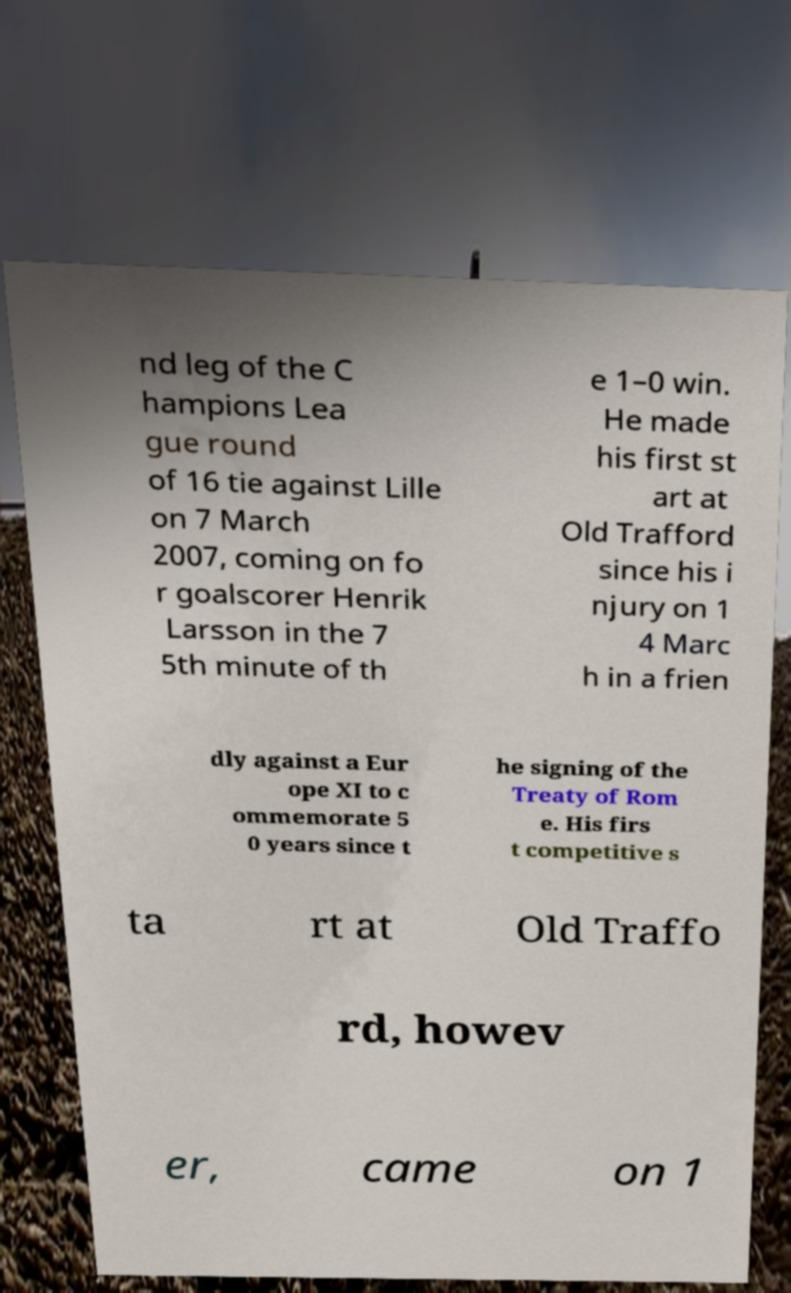Can you read and provide the text displayed in the image?This photo seems to have some interesting text. Can you extract and type it out for me? nd leg of the C hampions Lea gue round of 16 tie against Lille on 7 March 2007, coming on fo r goalscorer Henrik Larsson in the 7 5th minute of th e 1–0 win. He made his first st art at Old Trafford since his i njury on 1 4 Marc h in a frien dly against a Eur ope XI to c ommemorate 5 0 years since t he signing of the Treaty of Rom e. His firs t competitive s ta rt at Old Traffo rd, howev er, came on 1 